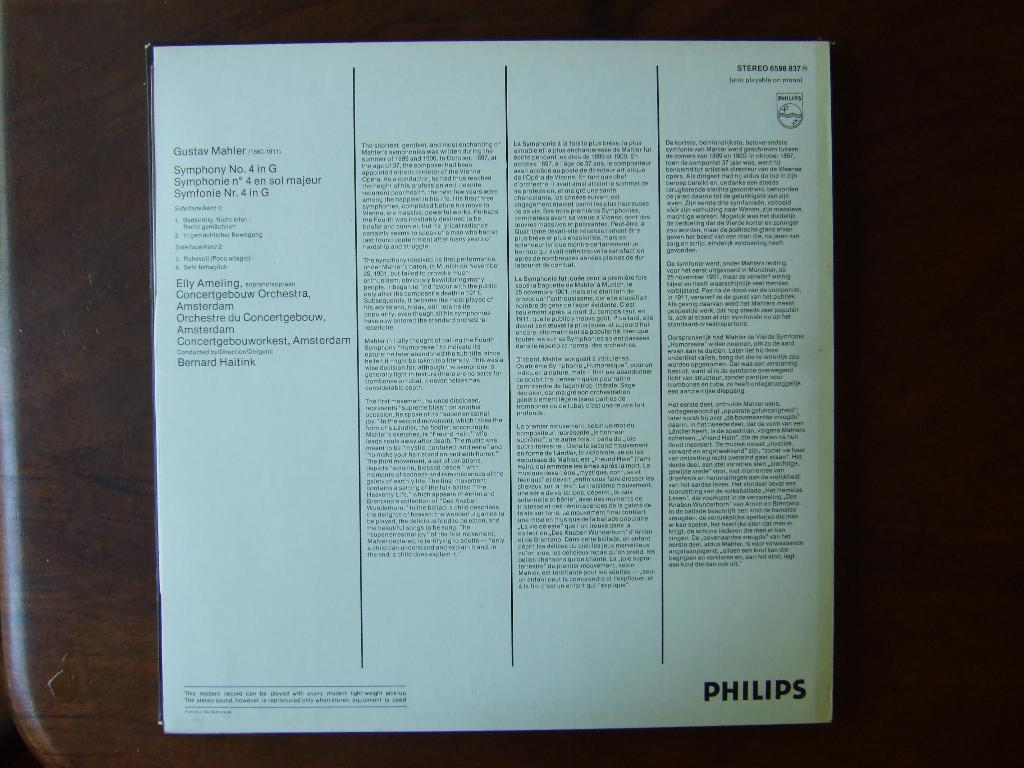Provide a one-sentence caption for the provided image. a book with words on the back and 'philips' written on the bottom right of it. 